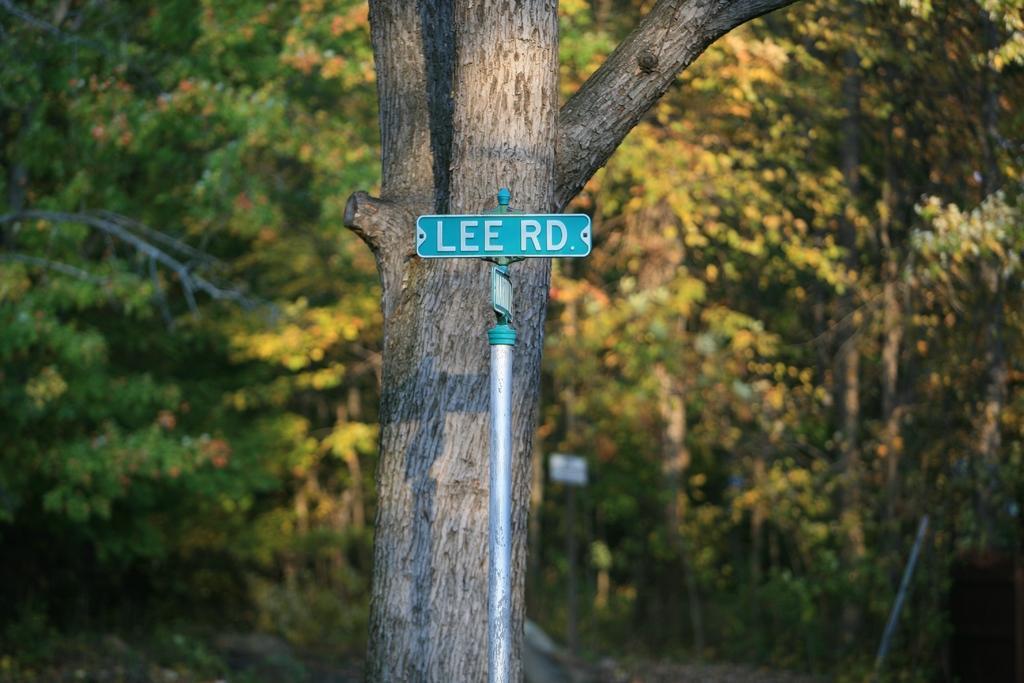In one or two sentences, can you explain what this image depicts? In this image there is a rod with a board attached to it. On the board there is some text, behind the road there is a tree. In the background there is are trees. 